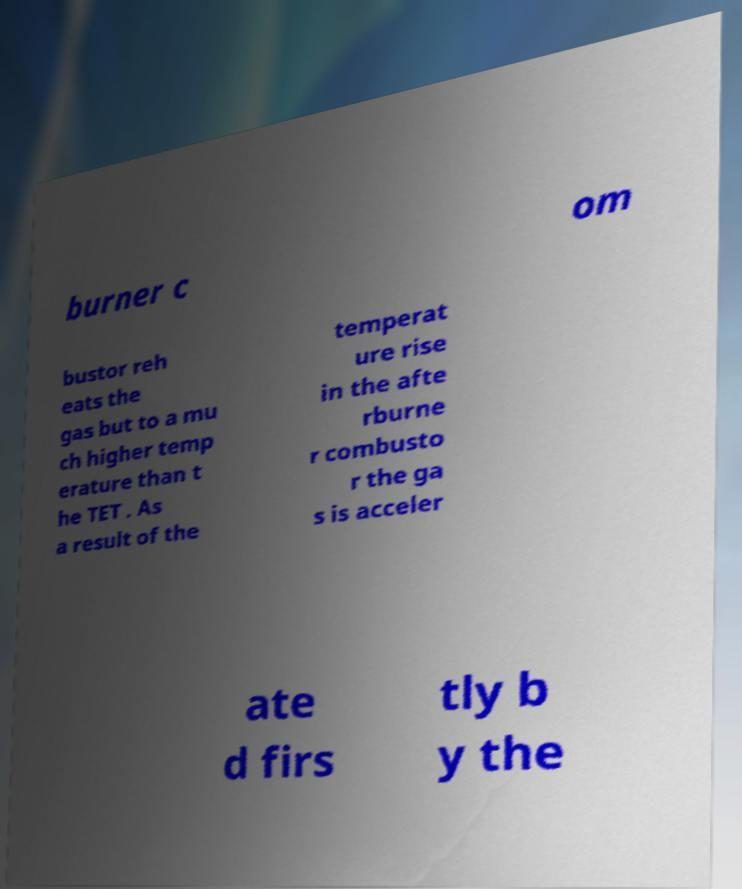Please read and relay the text visible in this image. What does it say? burner c om bustor reh eats the gas but to a mu ch higher temp erature than t he TET . As a result of the temperat ure rise in the afte rburne r combusto r the ga s is acceler ate d firs tly b y the 